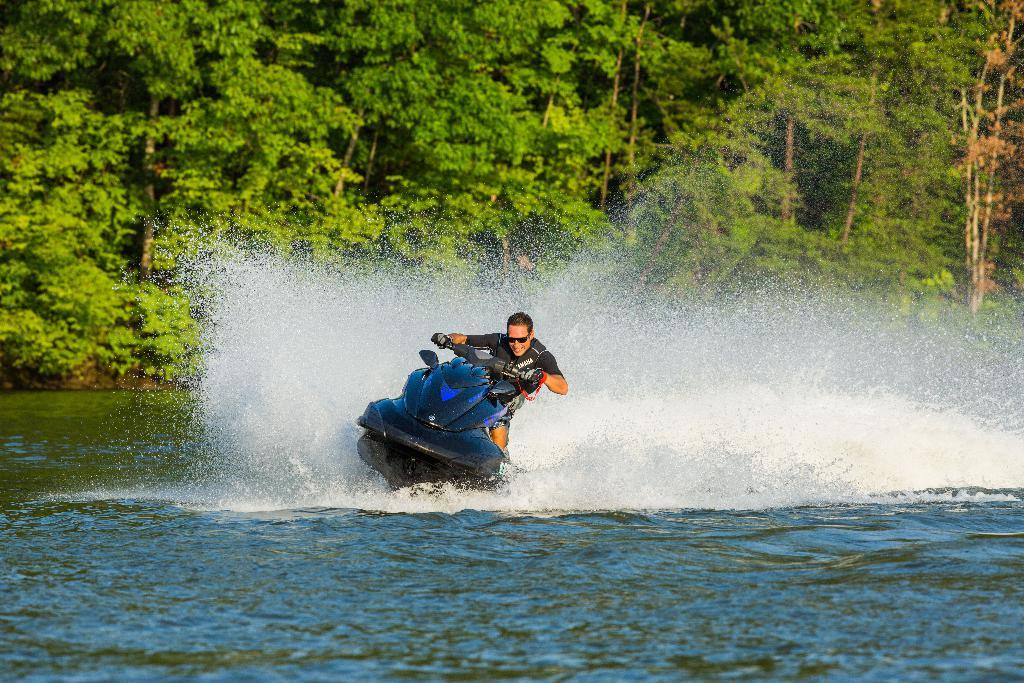What is visible in the image? There is water visible in the image. Can you describe the person in the image? There is a person wearing a black-colored dress in the image. What is the person doing in the image? The person is on a speedboat. What can be seen in the background of the image? There are trees in the background of the image. What colors are the trees in the image? The trees are green and brown in color. How many chairs are visible in the image? There are no chairs present in the image. What type of finger can be seen in the image? There are no fingers visible in the image. 